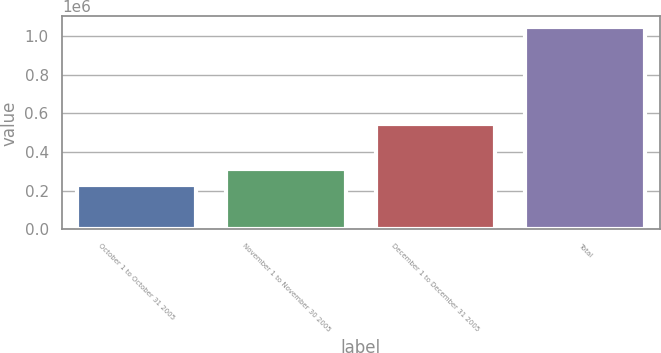<chart> <loc_0><loc_0><loc_500><loc_500><bar_chart><fcel>October 1 to October 31 2005<fcel>November 1 to November 30 2005<fcel>December 1 to December 31 2005<fcel>Total<nl><fcel>231000<fcel>312640<fcel>543400<fcel>1.0474e+06<nl></chart> 